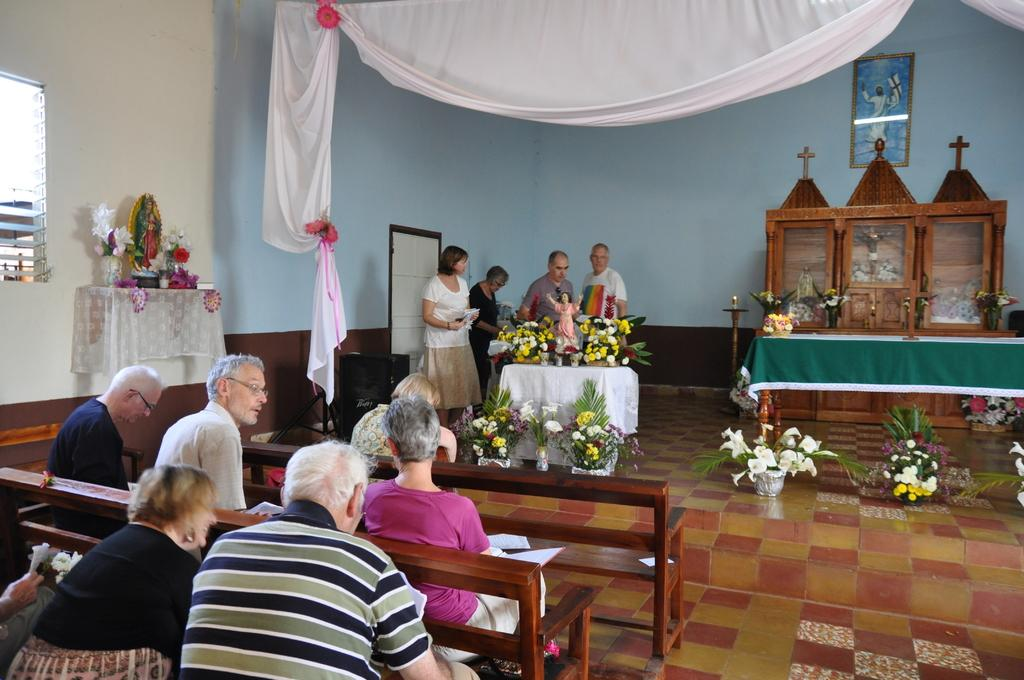What is the color of the wall in the image? The wall in the image is white. What type of furniture is present in the image? There is a table in the image. What kind of object can be seen on the table? There is a statue on the table in the image. What is placed object is used for displaying information in the image? There is a board in the image. What type of seating is available in the image? There are benches in the image. What are the people on the benches doing? There are people sitting on the benches in the image. What can be found on the floor in the image? There are bouquets on the floor in the image. What is the price of the letters on the board in the image? There are no letters on the board in the image, so it is not possible to determine a price. Can you tell me how many beans are on the floor in the image? There are no beans present in the image; only bouquets are on the floor. 